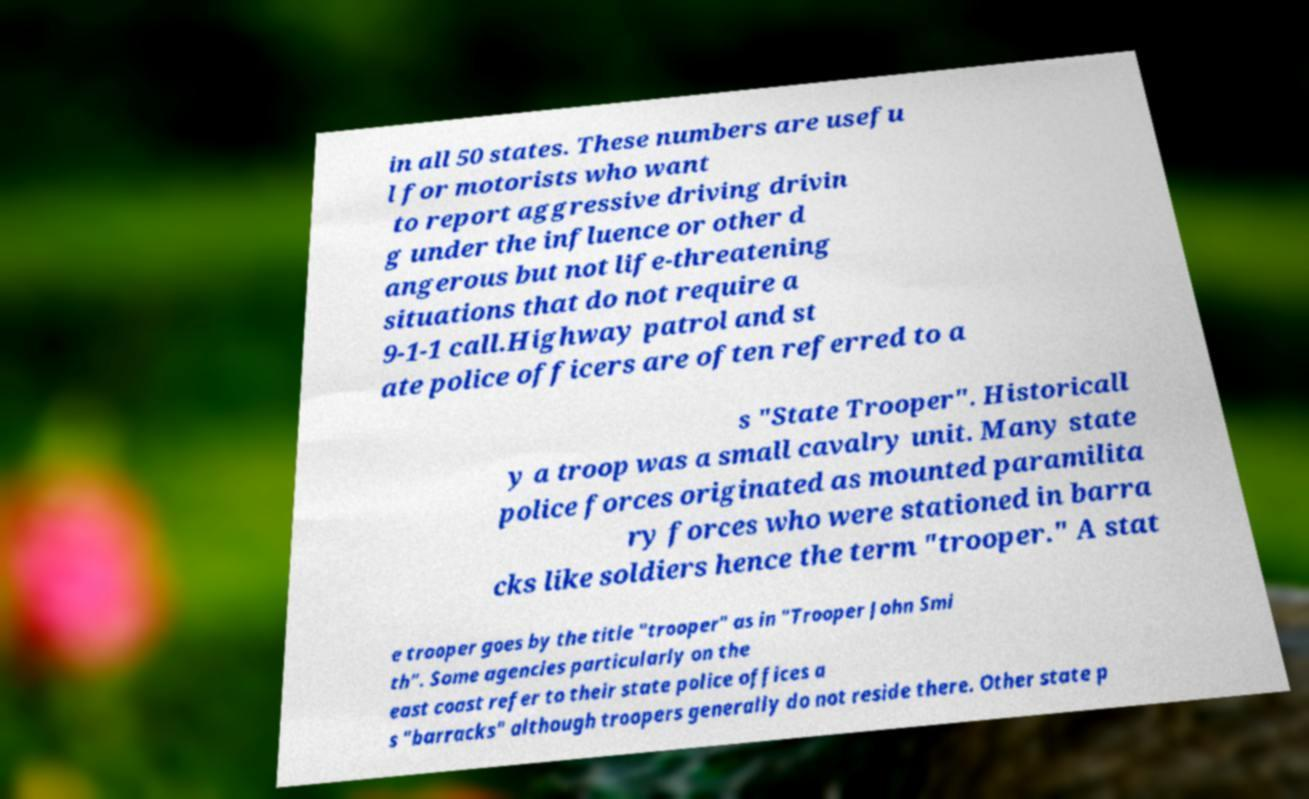Could you extract and type out the text from this image? in all 50 states. These numbers are usefu l for motorists who want to report aggressive driving drivin g under the influence or other d angerous but not life-threatening situations that do not require a 9-1-1 call.Highway patrol and st ate police officers are often referred to a s "State Trooper". Historicall y a troop was a small cavalry unit. Many state police forces originated as mounted paramilita ry forces who were stationed in barra cks like soldiers hence the term "trooper." A stat e trooper goes by the title "trooper" as in "Trooper John Smi th". Some agencies particularly on the east coast refer to their state police offices a s "barracks" although troopers generally do not reside there. Other state p 